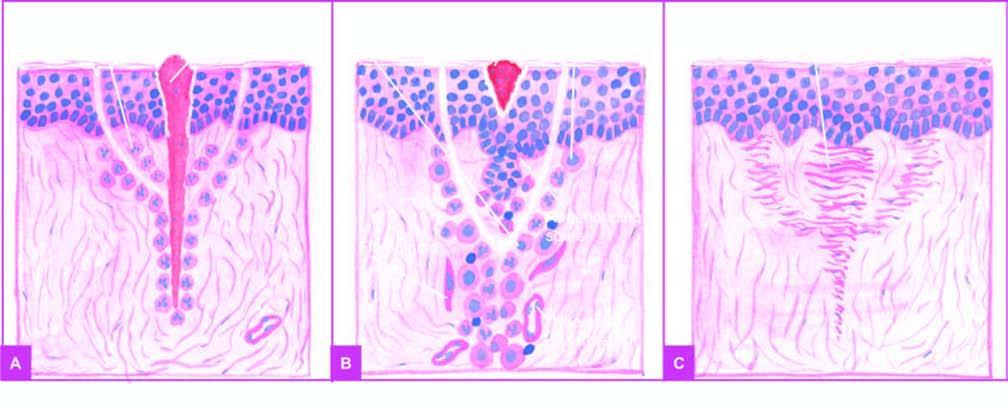what migrate along the incised margin on either side as well as around the suture track?
Answer the question using a single word or phrase. Spurs of epidermal cells 